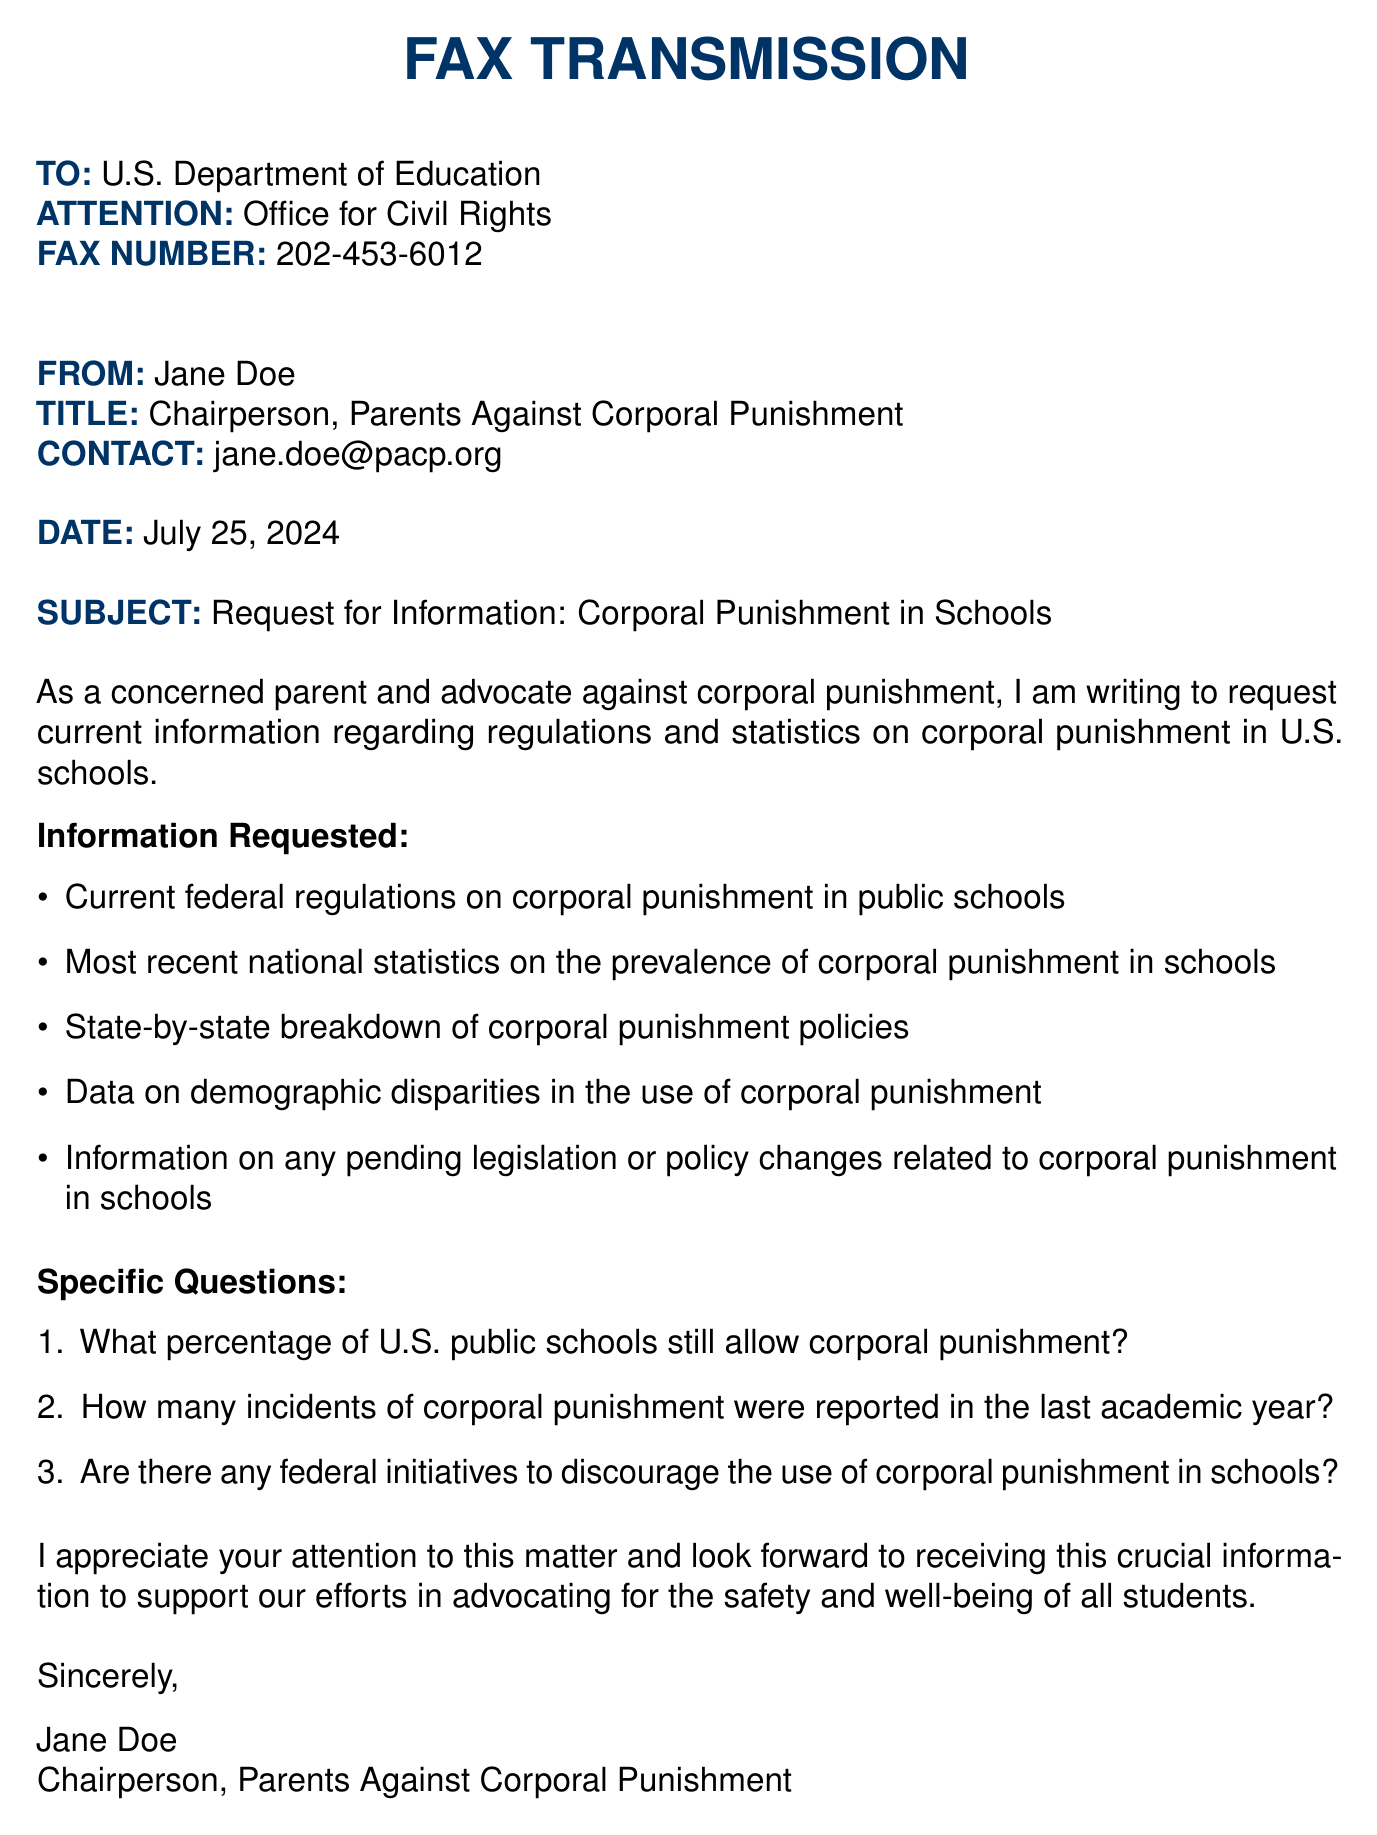What is the name of the sender? The sender is Jane Doe, who holds the title of Chairperson of Parents Against Corporal Punishment.
Answer: Jane Doe What is the subject of the fax? The subject clearly indicates that the fax is a request for information regarding corporal punishment in schools.
Answer: Request for Information: Corporal Punishment in Schools What is the fax number to which the document is sent? The fax number provided for the U.S. Department of Education is clearly stated to be 202-453-6012.
Answer: 202-453-6012 How many items are listed under Information Requested? The document lists a total of five specific items regarding regulations and statistics on corporal punishment.
Answer: 5 What percentage of U.S. public schools still allow corporal punishment? This specific question is included as one of the queries that Jane Doe is asking in the document.
Answer: ? Are there any federal initiatives to discourage corporal punishment? This is another specific question posed by the sender regarding federal actions related to corporal punishment.
Answer: ? Who is the recipient of the fax? The fax is addressed to the U.S. Department of Education, specifically to the Office for Civil Rights.
Answer: U.S. Department of Education What color is used for the header text? The header text is consistently colored in a specific shade referred to as "maincolor," which is RGB(0,51,102).
Answer: maincolor What is the confidentiality notice about? The confidentiality notice warns that the information contained in the fax is strictly prohibited for disclosure to unintended recipients.
Answer: Confidentiality notice 